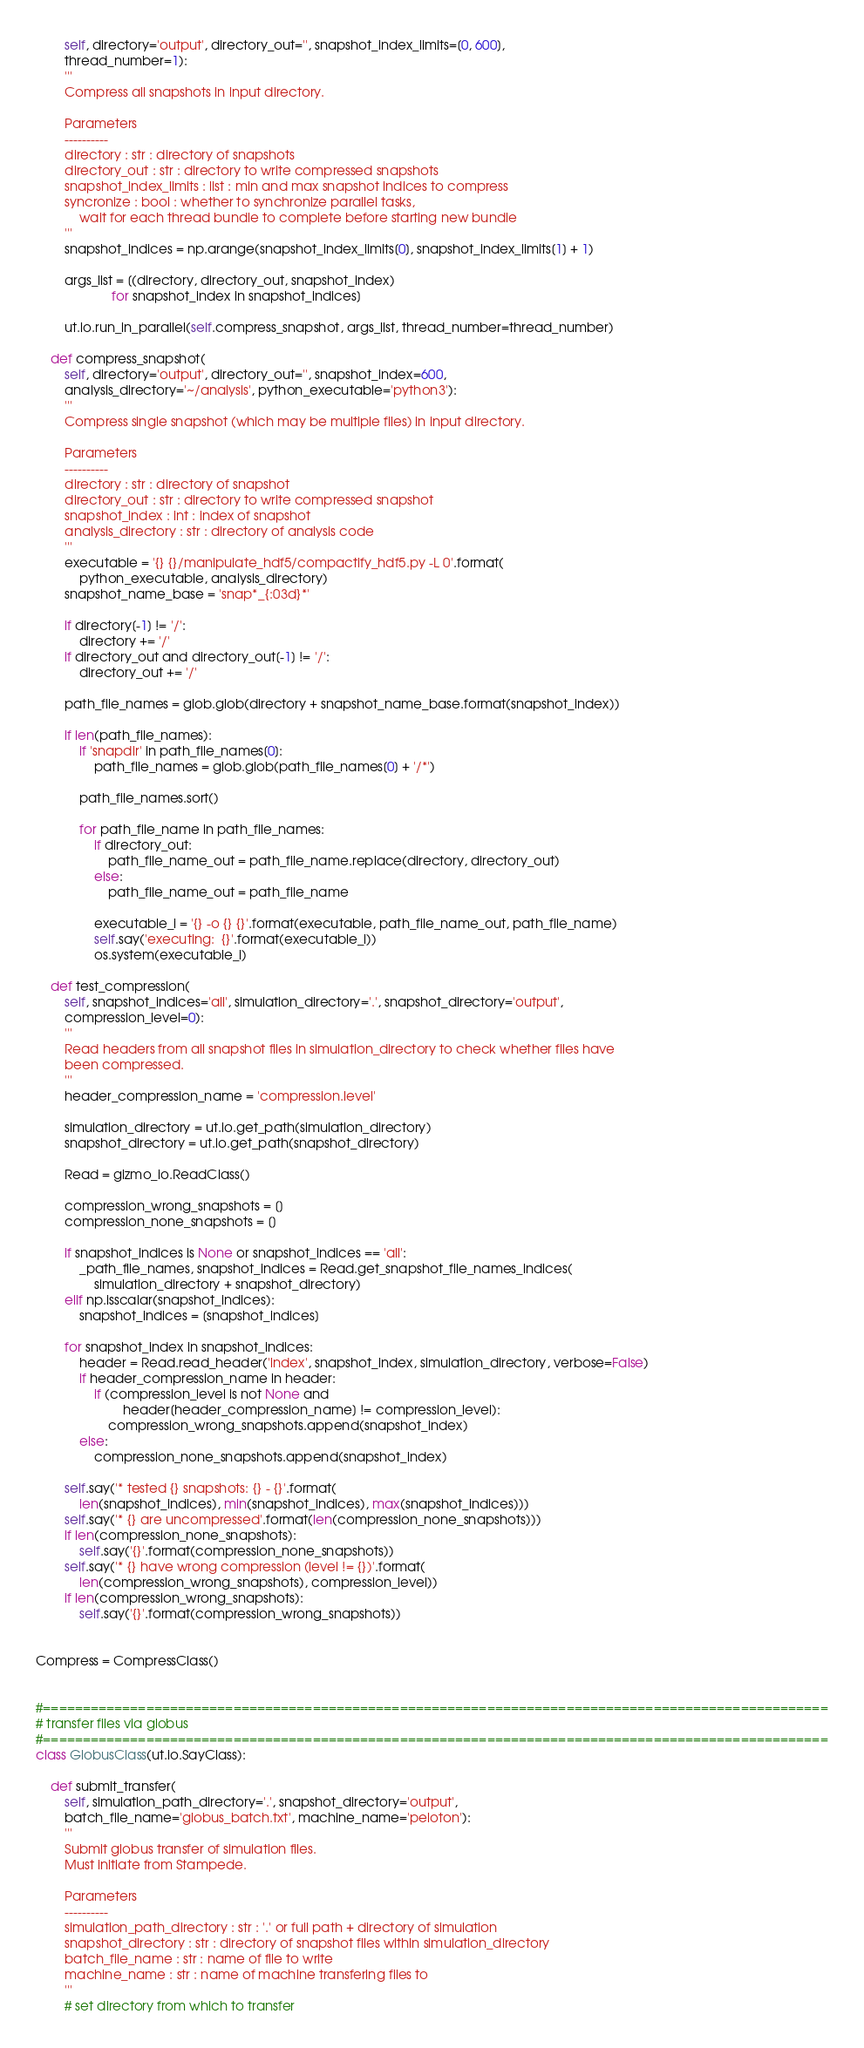<code> <loc_0><loc_0><loc_500><loc_500><_Python_>        self, directory='output', directory_out='', snapshot_index_limits=[0, 600],
        thread_number=1):
        '''
        Compress all snapshots in input directory.

        Parameters
        ----------
        directory : str : directory of snapshots
        directory_out : str : directory to write compressed snapshots
        snapshot_index_limits : list : min and max snapshot indices to compress
        syncronize : bool : whether to synchronize parallel tasks,
            wait for each thread bundle to complete before starting new bundle
        '''
        snapshot_indices = np.arange(snapshot_index_limits[0], snapshot_index_limits[1] + 1)

        args_list = [(directory, directory_out, snapshot_index)
                     for snapshot_index in snapshot_indices]

        ut.io.run_in_parallel(self.compress_snapshot, args_list, thread_number=thread_number)

    def compress_snapshot(
        self, directory='output', directory_out='', snapshot_index=600,
        analysis_directory='~/analysis', python_executable='python3'):
        '''
        Compress single snapshot (which may be multiple files) in input directory.

        Parameters
        ----------
        directory : str : directory of snapshot
        directory_out : str : directory to write compressed snapshot
        snapshot_index : int : index of snapshot
        analysis_directory : str : directory of analysis code
        '''
        executable = '{} {}/manipulate_hdf5/compactify_hdf5.py -L 0'.format(
            python_executable, analysis_directory)
        snapshot_name_base = 'snap*_{:03d}*'

        if directory[-1] != '/':
            directory += '/'
        if directory_out and directory_out[-1] != '/':
            directory_out += '/'

        path_file_names = glob.glob(directory + snapshot_name_base.format(snapshot_index))

        if len(path_file_names):
            if 'snapdir' in path_file_names[0]:
                path_file_names = glob.glob(path_file_names[0] + '/*')

            path_file_names.sort()

            for path_file_name in path_file_names:
                if directory_out:
                    path_file_name_out = path_file_name.replace(directory, directory_out)
                else:
                    path_file_name_out = path_file_name

                executable_i = '{} -o {} {}'.format(executable, path_file_name_out, path_file_name)
                self.say('executing:  {}'.format(executable_i))
                os.system(executable_i)

    def test_compression(
        self, snapshot_indices='all', simulation_directory='.', snapshot_directory='output',
        compression_level=0):
        '''
        Read headers from all snapshot files in simulation_directory to check whether files have
        been compressed.
        '''
        header_compression_name = 'compression.level'

        simulation_directory = ut.io.get_path(simulation_directory)
        snapshot_directory = ut.io.get_path(snapshot_directory)

        Read = gizmo_io.ReadClass()

        compression_wrong_snapshots = []
        compression_none_snapshots = []

        if snapshot_indices is None or snapshot_indices == 'all':
            _path_file_names, snapshot_indices = Read.get_snapshot_file_names_indices(
                simulation_directory + snapshot_directory)
        elif np.isscalar(snapshot_indices):
            snapshot_indices = [snapshot_indices]

        for snapshot_index in snapshot_indices:
            header = Read.read_header('index', snapshot_index, simulation_directory, verbose=False)
            if header_compression_name in header:
                if (compression_level is not None and
                        header[header_compression_name] != compression_level):
                    compression_wrong_snapshots.append(snapshot_index)
            else:
                compression_none_snapshots.append(snapshot_index)

        self.say('* tested {} snapshots: {} - {}'.format(
            len(snapshot_indices), min(snapshot_indices), max(snapshot_indices)))
        self.say('* {} are uncompressed'.format(len(compression_none_snapshots)))
        if len(compression_none_snapshots):
            self.say('{}'.format(compression_none_snapshots))
        self.say('* {} have wrong compression (level != {})'.format(
            len(compression_wrong_snapshots), compression_level))
        if len(compression_wrong_snapshots):
            self.say('{}'.format(compression_wrong_snapshots))


Compress = CompressClass()


#===================================================================================================
# transfer files via globus
#===================================================================================================
class GlobusClass(ut.io.SayClass):

    def submit_transfer(
        self, simulation_path_directory='.', snapshot_directory='output',
        batch_file_name='globus_batch.txt', machine_name='peloton'):
        '''
        Submit globus transfer of simulation files.
        Must initiate from Stampede.

        Parameters
        ----------
        simulation_path_directory : str : '.' or full path + directory of simulation
        snapshot_directory : str : directory of snapshot files within simulation_directory
        batch_file_name : str : name of file to write
        machine_name : str : name of machine transfering files to
        '''
        # set directory from which to transfer</code> 